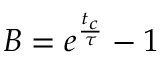<formula> <loc_0><loc_0><loc_500><loc_500>B = e ^ { \frac { t _ { c } } { \tau } } - 1</formula> 